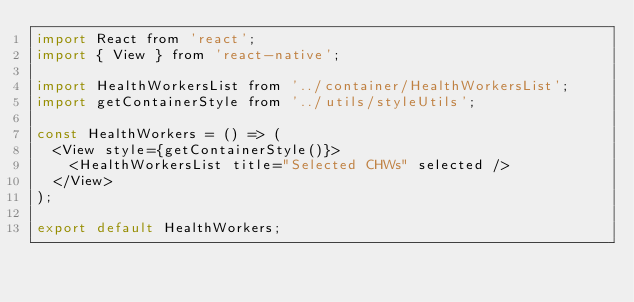<code> <loc_0><loc_0><loc_500><loc_500><_JavaScript_>import React from 'react';
import { View } from 'react-native';

import HealthWorkersList from '../container/HealthWorkersList';
import getContainerStyle from '../utils/styleUtils';

const HealthWorkers = () => (
  <View style={getContainerStyle()}>
    <HealthWorkersList title="Selected CHWs" selected />
  </View>
);

export default HealthWorkers;
</code> 